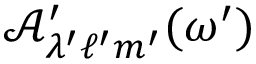Convert formula to latex. <formula><loc_0><loc_0><loc_500><loc_500>\mathcal { A ^ { \prime } } _ { \lambda ^ { \prime } \ell ^ { \prime } m ^ { \prime } } ( \omega ^ { \prime } )</formula> 